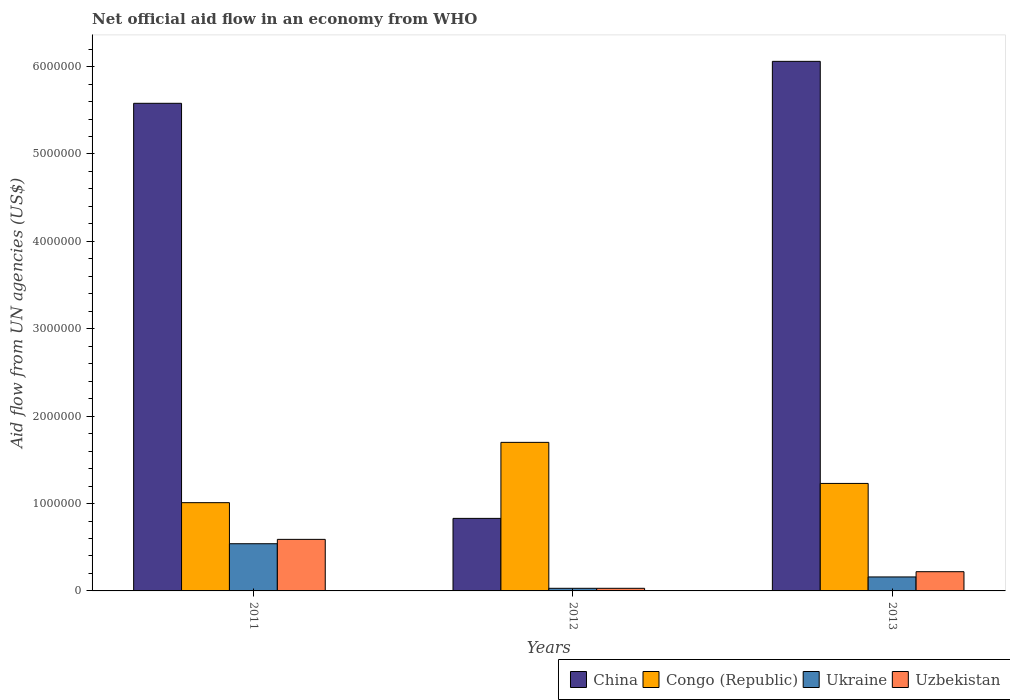Are the number of bars on each tick of the X-axis equal?
Ensure brevity in your answer.  Yes. How many bars are there on the 3rd tick from the left?
Ensure brevity in your answer.  4. How many bars are there on the 2nd tick from the right?
Your answer should be compact. 4. What is the label of the 3rd group of bars from the left?
Your answer should be very brief. 2013. Across all years, what is the maximum net official aid flow in China?
Offer a very short reply. 6.06e+06. Across all years, what is the minimum net official aid flow in China?
Your response must be concise. 8.30e+05. What is the total net official aid flow in China in the graph?
Your response must be concise. 1.25e+07. What is the difference between the net official aid flow in Uzbekistan in 2011 and that in 2012?
Keep it short and to the point. 5.60e+05. What is the difference between the net official aid flow in China in 2011 and the net official aid flow in Ukraine in 2013?
Provide a short and direct response. 5.42e+06. What is the average net official aid flow in China per year?
Keep it short and to the point. 4.16e+06. In the year 2012, what is the difference between the net official aid flow in Uzbekistan and net official aid flow in Congo (Republic)?
Give a very brief answer. -1.67e+06. In how many years, is the net official aid flow in China greater than 1000000 US$?
Give a very brief answer. 2. What is the ratio of the net official aid flow in Ukraine in 2011 to that in 2013?
Keep it short and to the point. 3.38. What is the difference between the highest and the lowest net official aid flow in Uzbekistan?
Provide a succinct answer. 5.60e+05. In how many years, is the net official aid flow in Uzbekistan greater than the average net official aid flow in Uzbekistan taken over all years?
Provide a short and direct response. 1. Is the sum of the net official aid flow in Uzbekistan in 2011 and 2013 greater than the maximum net official aid flow in Ukraine across all years?
Provide a short and direct response. Yes. Is it the case that in every year, the sum of the net official aid flow in Congo (Republic) and net official aid flow in Ukraine is greater than the sum of net official aid flow in Uzbekistan and net official aid flow in China?
Your answer should be compact. No. What does the 4th bar from the left in 2012 represents?
Your answer should be very brief. Uzbekistan. What does the 2nd bar from the right in 2012 represents?
Your answer should be compact. Ukraine. How many bars are there?
Provide a succinct answer. 12. What is the difference between two consecutive major ticks on the Y-axis?
Your answer should be very brief. 1.00e+06. How are the legend labels stacked?
Offer a very short reply. Horizontal. What is the title of the graph?
Keep it short and to the point. Net official aid flow in an economy from WHO. Does "Sint Maarten (Dutch part)" appear as one of the legend labels in the graph?
Provide a short and direct response. No. What is the label or title of the X-axis?
Offer a terse response. Years. What is the label or title of the Y-axis?
Give a very brief answer. Aid flow from UN agencies (US$). What is the Aid flow from UN agencies (US$) of China in 2011?
Ensure brevity in your answer.  5.58e+06. What is the Aid flow from UN agencies (US$) in Congo (Republic) in 2011?
Provide a succinct answer. 1.01e+06. What is the Aid flow from UN agencies (US$) of Ukraine in 2011?
Provide a short and direct response. 5.40e+05. What is the Aid flow from UN agencies (US$) in Uzbekistan in 2011?
Offer a terse response. 5.90e+05. What is the Aid flow from UN agencies (US$) of China in 2012?
Offer a very short reply. 8.30e+05. What is the Aid flow from UN agencies (US$) in Congo (Republic) in 2012?
Make the answer very short. 1.70e+06. What is the Aid flow from UN agencies (US$) of Ukraine in 2012?
Keep it short and to the point. 3.00e+04. What is the Aid flow from UN agencies (US$) in Uzbekistan in 2012?
Your response must be concise. 3.00e+04. What is the Aid flow from UN agencies (US$) in China in 2013?
Provide a short and direct response. 6.06e+06. What is the Aid flow from UN agencies (US$) in Congo (Republic) in 2013?
Ensure brevity in your answer.  1.23e+06. Across all years, what is the maximum Aid flow from UN agencies (US$) of China?
Ensure brevity in your answer.  6.06e+06. Across all years, what is the maximum Aid flow from UN agencies (US$) of Congo (Republic)?
Ensure brevity in your answer.  1.70e+06. Across all years, what is the maximum Aid flow from UN agencies (US$) of Ukraine?
Your answer should be very brief. 5.40e+05. Across all years, what is the maximum Aid flow from UN agencies (US$) of Uzbekistan?
Give a very brief answer. 5.90e+05. Across all years, what is the minimum Aid flow from UN agencies (US$) of China?
Provide a succinct answer. 8.30e+05. Across all years, what is the minimum Aid flow from UN agencies (US$) of Congo (Republic)?
Your response must be concise. 1.01e+06. Across all years, what is the minimum Aid flow from UN agencies (US$) of Ukraine?
Provide a succinct answer. 3.00e+04. Across all years, what is the minimum Aid flow from UN agencies (US$) in Uzbekistan?
Offer a very short reply. 3.00e+04. What is the total Aid flow from UN agencies (US$) in China in the graph?
Provide a short and direct response. 1.25e+07. What is the total Aid flow from UN agencies (US$) of Congo (Republic) in the graph?
Keep it short and to the point. 3.94e+06. What is the total Aid flow from UN agencies (US$) in Ukraine in the graph?
Your answer should be very brief. 7.30e+05. What is the total Aid flow from UN agencies (US$) in Uzbekistan in the graph?
Your response must be concise. 8.40e+05. What is the difference between the Aid flow from UN agencies (US$) of China in 2011 and that in 2012?
Keep it short and to the point. 4.75e+06. What is the difference between the Aid flow from UN agencies (US$) in Congo (Republic) in 2011 and that in 2012?
Your answer should be very brief. -6.90e+05. What is the difference between the Aid flow from UN agencies (US$) of Ukraine in 2011 and that in 2012?
Your answer should be very brief. 5.10e+05. What is the difference between the Aid flow from UN agencies (US$) in Uzbekistan in 2011 and that in 2012?
Ensure brevity in your answer.  5.60e+05. What is the difference between the Aid flow from UN agencies (US$) in China in 2011 and that in 2013?
Make the answer very short. -4.80e+05. What is the difference between the Aid flow from UN agencies (US$) in Congo (Republic) in 2011 and that in 2013?
Your answer should be very brief. -2.20e+05. What is the difference between the Aid flow from UN agencies (US$) in Ukraine in 2011 and that in 2013?
Ensure brevity in your answer.  3.80e+05. What is the difference between the Aid flow from UN agencies (US$) of China in 2012 and that in 2013?
Your response must be concise. -5.23e+06. What is the difference between the Aid flow from UN agencies (US$) in Congo (Republic) in 2012 and that in 2013?
Your answer should be compact. 4.70e+05. What is the difference between the Aid flow from UN agencies (US$) of Ukraine in 2012 and that in 2013?
Offer a terse response. -1.30e+05. What is the difference between the Aid flow from UN agencies (US$) of China in 2011 and the Aid flow from UN agencies (US$) of Congo (Republic) in 2012?
Offer a very short reply. 3.88e+06. What is the difference between the Aid flow from UN agencies (US$) of China in 2011 and the Aid flow from UN agencies (US$) of Ukraine in 2012?
Your response must be concise. 5.55e+06. What is the difference between the Aid flow from UN agencies (US$) in China in 2011 and the Aid flow from UN agencies (US$) in Uzbekistan in 2012?
Make the answer very short. 5.55e+06. What is the difference between the Aid flow from UN agencies (US$) of Congo (Republic) in 2011 and the Aid flow from UN agencies (US$) of Ukraine in 2012?
Your answer should be compact. 9.80e+05. What is the difference between the Aid flow from UN agencies (US$) of Congo (Republic) in 2011 and the Aid flow from UN agencies (US$) of Uzbekistan in 2012?
Make the answer very short. 9.80e+05. What is the difference between the Aid flow from UN agencies (US$) in Ukraine in 2011 and the Aid flow from UN agencies (US$) in Uzbekistan in 2012?
Ensure brevity in your answer.  5.10e+05. What is the difference between the Aid flow from UN agencies (US$) in China in 2011 and the Aid flow from UN agencies (US$) in Congo (Republic) in 2013?
Make the answer very short. 4.35e+06. What is the difference between the Aid flow from UN agencies (US$) in China in 2011 and the Aid flow from UN agencies (US$) in Ukraine in 2013?
Your answer should be compact. 5.42e+06. What is the difference between the Aid flow from UN agencies (US$) in China in 2011 and the Aid flow from UN agencies (US$) in Uzbekistan in 2013?
Offer a very short reply. 5.36e+06. What is the difference between the Aid flow from UN agencies (US$) of Congo (Republic) in 2011 and the Aid flow from UN agencies (US$) of Ukraine in 2013?
Give a very brief answer. 8.50e+05. What is the difference between the Aid flow from UN agencies (US$) in Congo (Republic) in 2011 and the Aid flow from UN agencies (US$) in Uzbekistan in 2013?
Make the answer very short. 7.90e+05. What is the difference between the Aid flow from UN agencies (US$) of China in 2012 and the Aid flow from UN agencies (US$) of Congo (Republic) in 2013?
Offer a terse response. -4.00e+05. What is the difference between the Aid flow from UN agencies (US$) of China in 2012 and the Aid flow from UN agencies (US$) of Ukraine in 2013?
Offer a terse response. 6.70e+05. What is the difference between the Aid flow from UN agencies (US$) of Congo (Republic) in 2012 and the Aid flow from UN agencies (US$) of Ukraine in 2013?
Offer a very short reply. 1.54e+06. What is the difference between the Aid flow from UN agencies (US$) of Congo (Republic) in 2012 and the Aid flow from UN agencies (US$) of Uzbekistan in 2013?
Ensure brevity in your answer.  1.48e+06. What is the difference between the Aid flow from UN agencies (US$) of Ukraine in 2012 and the Aid flow from UN agencies (US$) of Uzbekistan in 2013?
Offer a terse response. -1.90e+05. What is the average Aid flow from UN agencies (US$) of China per year?
Your answer should be compact. 4.16e+06. What is the average Aid flow from UN agencies (US$) of Congo (Republic) per year?
Offer a terse response. 1.31e+06. What is the average Aid flow from UN agencies (US$) in Ukraine per year?
Offer a terse response. 2.43e+05. What is the average Aid flow from UN agencies (US$) in Uzbekistan per year?
Provide a short and direct response. 2.80e+05. In the year 2011, what is the difference between the Aid flow from UN agencies (US$) in China and Aid flow from UN agencies (US$) in Congo (Republic)?
Ensure brevity in your answer.  4.57e+06. In the year 2011, what is the difference between the Aid flow from UN agencies (US$) of China and Aid flow from UN agencies (US$) of Ukraine?
Your answer should be very brief. 5.04e+06. In the year 2011, what is the difference between the Aid flow from UN agencies (US$) of China and Aid flow from UN agencies (US$) of Uzbekistan?
Offer a very short reply. 4.99e+06. In the year 2011, what is the difference between the Aid flow from UN agencies (US$) of Congo (Republic) and Aid flow from UN agencies (US$) of Ukraine?
Make the answer very short. 4.70e+05. In the year 2011, what is the difference between the Aid flow from UN agencies (US$) of Congo (Republic) and Aid flow from UN agencies (US$) of Uzbekistan?
Your answer should be very brief. 4.20e+05. In the year 2011, what is the difference between the Aid flow from UN agencies (US$) of Ukraine and Aid flow from UN agencies (US$) of Uzbekistan?
Ensure brevity in your answer.  -5.00e+04. In the year 2012, what is the difference between the Aid flow from UN agencies (US$) of China and Aid flow from UN agencies (US$) of Congo (Republic)?
Make the answer very short. -8.70e+05. In the year 2012, what is the difference between the Aid flow from UN agencies (US$) of China and Aid flow from UN agencies (US$) of Uzbekistan?
Give a very brief answer. 8.00e+05. In the year 2012, what is the difference between the Aid flow from UN agencies (US$) in Congo (Republic) and Aid flow from UN agencies (US$) in Ukraine?
Give a very brief answer. 1.67e+06. In the year 2012, what is the difference between the Aid flow from UN agencies (US$) in Congo (Republic) and Aid flow from UN agencies (US$) in Uzbekistan?
Provide a short and direct response. 1.67e+06. In the year 2012, what is the difference between the Aid flow from UN agencies (US$) of Ukraine and Aid flow from UN agencies (US$) of Uzbekistan?
Provide a succinct answer. 0. In the year 2013, what is the difference between the Aid flow from UN agencies (US$) in China and Aid flow from UN agencies (US$) in Congo (Republic)?
Offer a terse response. 4.83e+06. In the year 2013, what is the difference between the Aid flow from UN agencies (US$) in China and Aid flow from UN agencies (US$) in Ukraine?
Your answer should be very brief. 5.90e+06. In the year 2013, what is the difference between the Aid flow from UN agencies (US$) in China and Aid flow from UN agencies (US$) in Uzbekistan?
Ensure brevity in your answer.  5.84e+06. In the year 2013, what is the difference between the Aid flow from UN agencies (US$) of Congo (Republic) and Aid flow from UN agencies (US$) of Ukraine?
Provide a short and direct response. 1.07e+06. In the year 2013, what is the difference between the Aid flow from UN agencies (US$) of Congo (Republic) and Aid flow from UN agencies (US$) of Uzbekistan?
Your answer should be very brief. 1.01e+06. What is the ratio of the Aid flow from UN agencies (US$) of China in 2011 to that in 2012?
Your response must be concise. 6.72. What is the ratio of the Aid flow from UN agencies (US$) of Congo (Republic) in 2011 to that in 2012?
Your answer should be compact. 0.59. What is the ratio of the Aid flow from UN agencies (US$) in Uzbekistan in 2011 to that in 2012?
Offer a very short reply. 19.67. What is the ratio of the Aid flow from UN agencies (US$) of China in 2011 to that in 2013?
Make the answer very short. 0.92. What is the ratio of the Aid flow from UN agencies (US$) in Congo (Republic) in 2011 to that in 2013?
Give a very brief answer. 0.82. What is the ratio of the Aid flow from UN agencies (US$) in Ukraine in 2011 to that in 2013?
Provide a succinct answer. 3.38. What is the ratio of the Aid flow from UN agencies (US$) of Uzbekistan in 2011 to that in 2013?
Ensure brevity in your answer.  2.68. What is the ratio of the Aid flow from UN agencies (US$) in China in 2012 to that in 2013?
Ensure brevity in your answer.  0.14. What is the ratio of the Aid flow from UN agencies (US$) of Congo (Republic) in 2012 to that in 2013?
Ensure brevity in your answer.  1.38. What is the ratio of the Aid flow from UN agencies (US$) of Ukraine in 2012 to that in 2013?
Give a very brief answer. 0.19. What is the ratio of the Aid flow from UN agencies (US$) in Uzbekistan in 2012 to that in 2013?
Provide a short and direct response. 0.14. What is the difference between the highest and the second highest Aid flow from UN agencies (US$) in Congo (Republic)?
Make the answer very short. 4.70e+05. What is the difference between the highest and the second highest Aid flow from UN agencies (US$) of Uzbekistan?
Make the answer very short. 3.70e+05. What is the difference between the highest and the lowest Aid flow from UN agencies (US$) in China?
Your answer should be compact. 5.23e+06. What is the difference between the highest and the lowest Aid flow from UN agencies (US$) in Congo (Republic)?
Keep it short and to the point. 6.90e+05. What is the difference between the highest and the lowest Aid flow from UN agencies (US$) of Ukraine?
Provide a succinct answer. 5.10e+05. What is the difference between the highest and the lowest Aid flow from UN agencies (US$) in Uzbekistan?
Your response must be concise. 5.60e+05. 